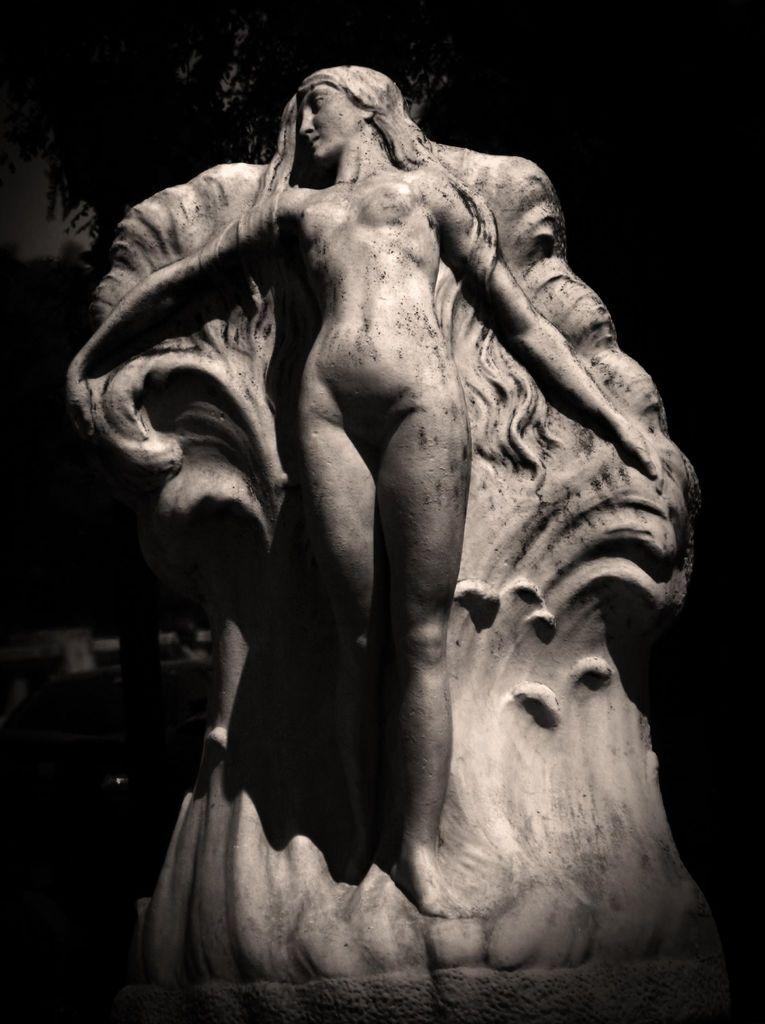What is the main subject of the image? There is a sculpture of a person in the image. What can be observed about the background of the image? The background of the image is dark. What level of experience does the beginner have with the stick in the image? There is no stick or beginner present in the image. 